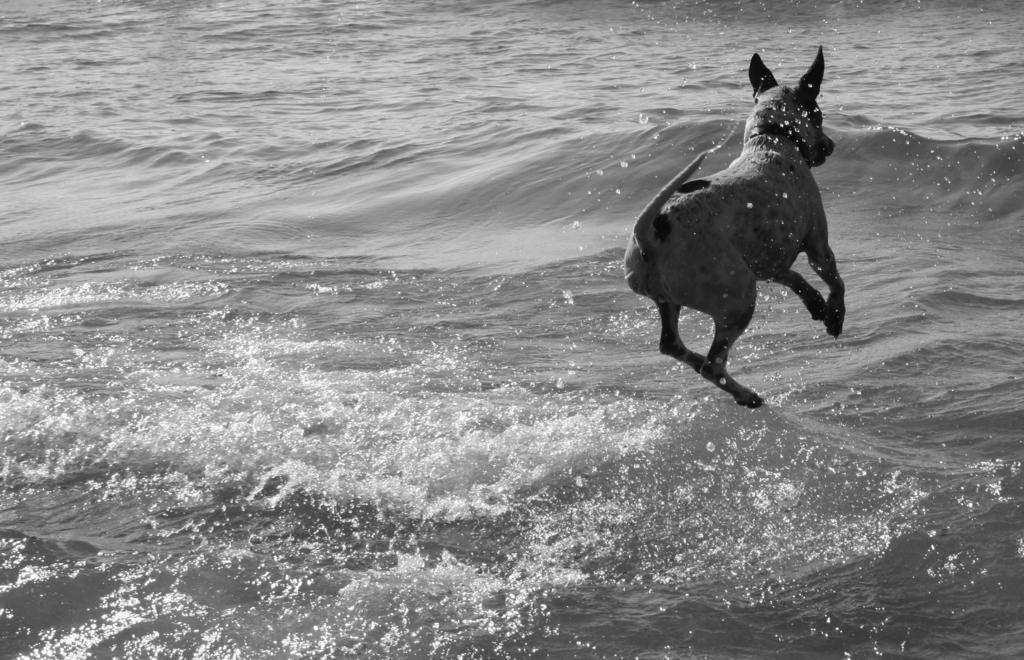What is the color scheme of the image? The image is black and white. What animal can be seen in the image? There is a dog in the image. What is present at the bottom of the image? There is water at the bottom of the image. What type of beef is being stored in the jar in the image? There is no jar or beef present in the image. What is the governor's opinion on the dog in the image? There is no reference to a governor or their opinion in the image. 